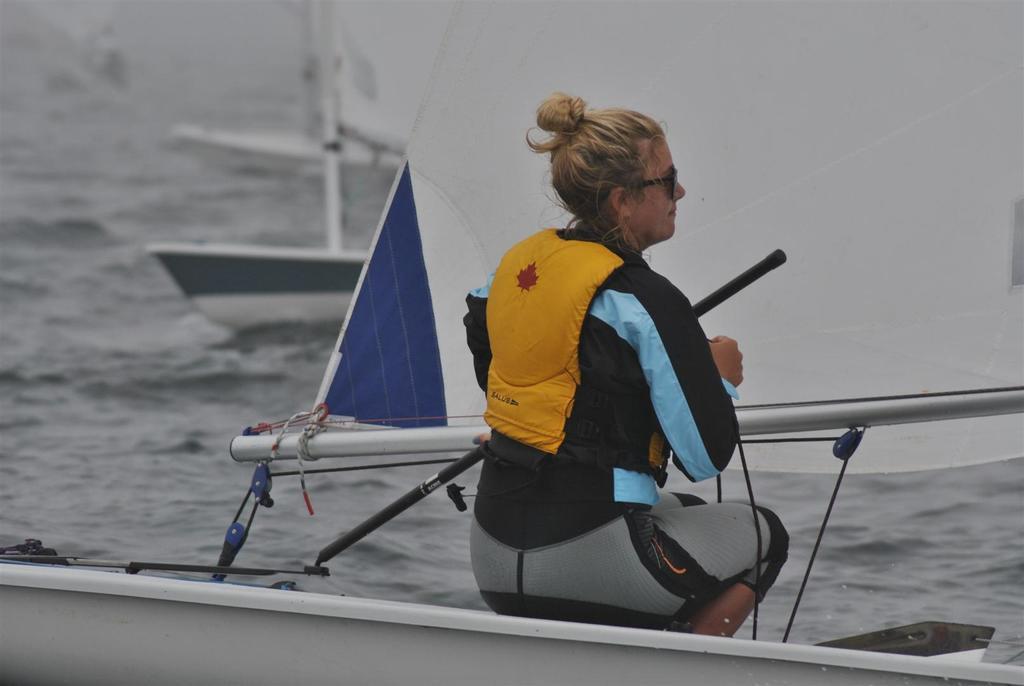Can you describe this image briefly? In this image I can see a woman wearing yellow, grey, black and blue colored dress is sitting on a boat. In the background I can see the water and few other boats. 